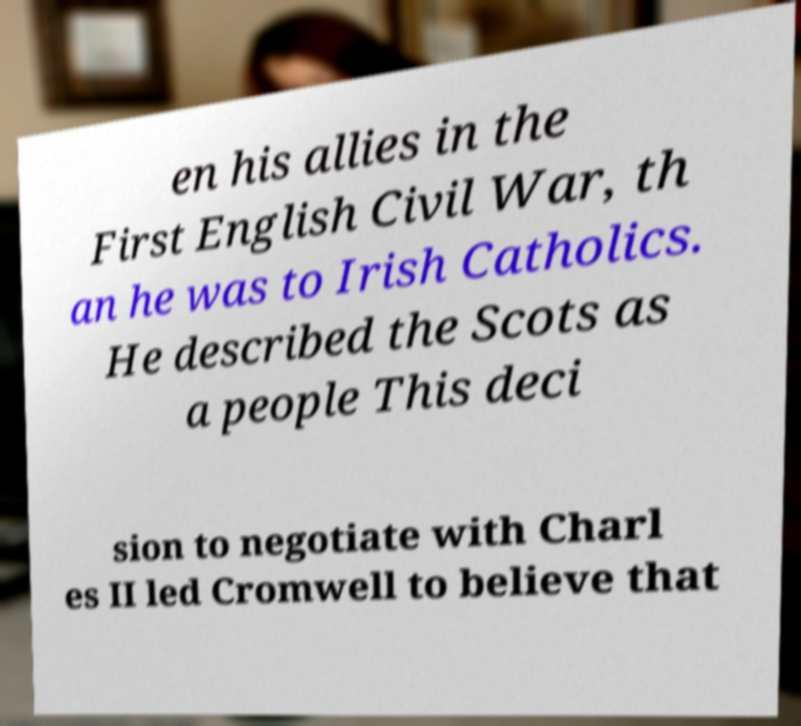Could you assist in decoding the text presented in this image and type it out clearly? en his allies in the First English Civil War, th an he was to Irish Catholics. He described the Scots as a people This deci sion to negotiate with Charl es II led Cromwell to believe that 